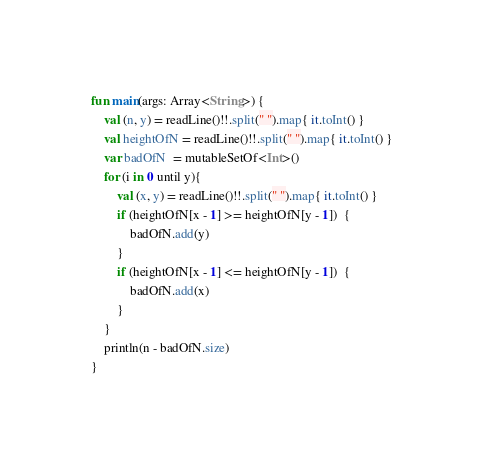Convert code to text. <code><loc_0><loc_0><loc_500><loc_500><_Kotlin_>fun main(args: Array<String>) {
    val (n, y) = readLine()!!.split(" ").map{ it.toInt() }
    val heightOfN = readLine()!!.split(" ").map{ it.toInt() }
    var badOfN  = mutableSetOf<Int>()
    for (i in 0 until y){
        val (x, y) = readLine()!!.split(" ").map{ it.toInt() }
        if (heightOfN[x - 1] >= heightOfN[y - 1])  {
            badOfN.add(y)
        }
        if (heightOfN[x - 1] <= heightOfN[y - 1])  {
            badOfN.add(x)
        }
    }
    println(n - badOfN.size)
}
</code> 